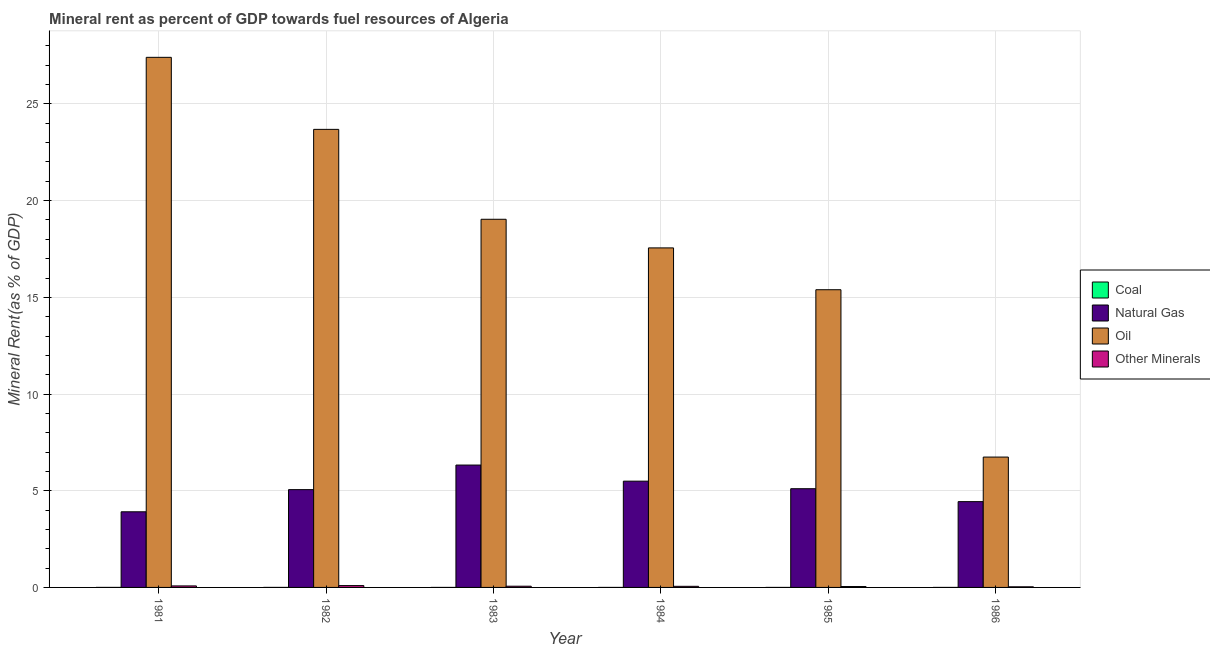How many groups of bars are there?
Provide a short and direct response. 6. Are the number of bars per tick equal to the number of legend labels?
Your response must be concise. Yes. Are the number of bars on each tick of the X-axis equal?
Make the answer very short. Yes. How many bars are there on the 2nd tick from the left?
Offer a terse response. 4. What is the label of the 1st group of bars from the left?
Your answer should be very brief. 1981. In how many cases, is the number of bars for a given year not equal to the number of legend labels?
Provide a short and direct response. 0. What is the oil rent in 1985?
Offer a terse response. 15.39. Across all years, what is the maximum  rent of other minerals?
Offer a very short reply. 0.09. Across all years, what is the minimum oil rent?
Provide a short and direct response. 6.74. In which year was the coal rent maximum?
Keep it short and to the point. 1982. In which year was the coal rent minimum?
Your response must be concise. 1986. What is the total natural gas rent in the graph?
Give a very brief answer. 30.33. What is the difference between the  rent of other minerals in 1982 and that in 1984?
Make the answer very short. 0.04. What is the difference between the natural gas rent in 1982 and the  rent of other minerals in 1986?
Ensure brevity in your answer.  0.62. What is the average coal rent per year?
Make the answer very short. 0. In how many years, is the  rent of other minerals greater than 21 %?
Your response must be concise. 0. What is the ratio of the  rent of other minerals in 1982 to that in 1984?
Your answer should be compact. 1.66. What is the difference between the highest and the second highest  rent of other minerals?
Ensure brevity in your answer.  0.02. What is the difference between the highest and the lowest  rent of other minerals?
Provide a succinct answer. 0.06. What does the 1st bar from the left in 1984 represents?
Your answer should be very brief. Coal. What does the 1st bar from the right in 1985 represents?
Give a very brief answer. Other Minerals. How many bars are there?
Your answer should be very brief. 24. Are all the bars in the graph horizontal?
Offer a very short reply. No. How many years are there in the graph?
Offer a very short reply. 6. What is the difference between two consecutive major ticks on the Y-axis?
Offer a very short reply. 5. Are the values on the major ticks of Y-axis written in scientific E-notation?
Your answer should be very brief. No. Does the graph contain any zero values?
Your answer should be compact. No. Does the graph contain grids?
Provide a short and direct response. Yes. What is the title of the graph?
Offer a terse response. Mineral rent as percent of GDP towards fuel resources of Algeria. What is the label or title of the Y-axis?
Ensure brevity in your answer.  Mineral Rent(as % of GDP). What is the Mineral Rent(as % of GDP) of Coal in 1981?
Your answer should be very brief. 0. What is the Mineral Rent(as % of GDP) in Natural Gas in 1981?
Make the answer very short. 3.91. What is the Mineral Rent(as % of GDP) in Oil in 1981?
Make the answer very short. 27.41. What is the Mineral Rent(as % of GDP) of Other Minerals in 1981?
Keep it short and to the point. 0.08. What is the Mineral Rent(as % of GDP) in Coal in 1982?
Make the answer very short. 0. What is the Mineral Rent(as % of GDP) of Natural Gas in 1982?
Provide a succinct answer. 5.06. What is the Mineral Rent(as % of GDP) in Oil in 1982?
Your answer should be compact. 23.69. What is the Mineral Rent(as % of GDP) of Other Minerals in 1982?
Ensure brevity in your answer.  0.09. What is the Mineral Rent(as % of GDP) of Coal in 1983?
Your answer should be compact. 0. What is the Mineral Rent(as % of GDP) in Natural Gas in 1983?
Your answer should be compact. 6.33. What is the Mineral Rent(as % of GDP) of Oil in 1983?
Your answer should be very brief. 19.04. What is the Mineral Rent(as % of GDP) of Other Minerals in 1983?
Give a very brief answer. 0.06. What is the Mineral Rent(as % of GDP) of Coal in 1984?
Your answer should be very brief. 6.52912655872695e-5. What is the Mineral Rent(as % of GDP) of Natural Gas in 1984?
Your response must be concise. 5.49. What is the Mineral Rent(as % of GDP) in Oil in 1984?
Provide a short and direct response. 17.56. What is the Mineral Rent(as % of GDP) of Other Minerals in 1984?
Your answer should be compact. 0.06. What is the Mineral Rent(as % of GDP) in Coal in 1985?
Keep it short and to the point. 0. What is the Mineral Rent(as % of GDP) in Natural Gas in 1985?
Your answer should be compact. 5.1. What is the Mineral Rent(as % of GDP) in Oil in 1985?
Provide a succinct answer. 15.39. What is the Mineral Rent(as % of GDP) of Other Minerals in 1985?
Offer a very short reply. 0.05. What is the Mineral Rent(as % of GDP) in Coal in 1986?
Provide a short and direct response. 1.11843058632871e-6. What is the Mineral Rent(as % of GDP) in Natural Gas in 1986?
Your answer should be very brief. 4.44. What is the Mineral Rent(as % of GDP) in Oil in 1986?
Offer a terse response. 6.74. What is the Mineral Rent(as % of GDP) in Other Minerals in 1986?
Provide a short and direct response. 0.03. Across all years, what is the maximum Mineral Rent(as % of GDP) of Coal?
Your answer should be very brief. 0. Across all years, what is the maximum Mineral Rent(as % of GDP) of Natural Gas?
Keep it short and to the point. 6.33. Across all years, what is the maximum Mineral Rent(as % of GDP) of Oil?
Your response must be concise. 27.41. Across all years, what is the maximum Mineral Rent(as % of GDP) of Other Minerals?
Offer a very short reply. 0.09. Across all years, what is the minimum Mineral Rent(as % of GDP) in Coal?
Make the answer very short. 1.11843058632871e-6. Across all years, what is the minimum Mineral Rent(as % of GDP) in Natural Gas?
Provide a succinct answer. 3.91. Across all years, what is the minimum Mineral Rent(as % of GDP) in Oil?
Offer a very short reply. 6.74. Across all years, what is the minimum Mineral Rent(as % of GDP) in Other Minerals?
Make the answer very short. 0.03. What is the total Mineral Rent(as % of GDP) of Coal in the graph?
Your answer should be compact. 0. What is the total Mineral Rent(as % of GDP) in Natural Gas in the graph?
Make the answer very short. 30.33. What is the total Mineral Rent(as % of GDP) in Oil in the graph?
Provide a short and direct response. 109.82. What is the total Mineral Rent(as % of GDP) of Other Minerals in the graph?
Give a very brief answer. 0.37. What is the difference between the Mineral Rent(as % of GDP) of Natural Gas in 1981 and that in 1982?
Your response must be concise. -1.15. What is the difference between the Mineral Rent(as % of GDP) of Oil in 1981 and that in 1982?
Provide a short and direct response. 3.73. What is the difference between the Mineral Rent(as % of GDP) of Other Minerals in 1981 and that in 1982?
Make the answer very short. -0.02. What is the difference between the Mineral Rent(as % of GDP) in Coal in 1981 and that in 1983?
Your answer should be compact. 0. What is the difference between the Mineral Rent(as % of GDP) in Natural Gas in 1981 and that in 1983?
Give a very brief answer. -2.42. What is the difference between the Mineral Rent(as % of GDP) of Oil in 1981 and that in 1983?
Give a very brief answer. 8.37. What is the difference between the Mineral Rent(as % of GDP) in Other Minerals in 1981 and that in 1983?
Offer a terse response. 0.02. What is the difference between the Mineral Rent(as % of GDP) of Coal in 1981 and that in 1984?
Offer a terse response. 0. What is the difference between the Mineral Rent(as % of GDP) of Natural Gas in 1981 and that in 1984?
Give a very brief answer. -1.58. What is the difference between the Mineral Rent(as % of GDP) of Oil in 1981 and that in 1984?
Give a very brief answer. 9.85. What is the difference between the Mineral Rent(as % of GDP) in Other Minerals in 1981 and that in 1984?
Offer a very short reply. 0.02. What is the difference between the Mineral Rent(as % of GDP) in Coal in 1981 and that in 1985?
Give a very brief answer. 0. What is the difference between the Mineral Rent(as % of GDP) of Natural Gas in 1981 and that in 1985?
Provide a succinct answer. -1.19. What is the difference between the Mineral Rent(as % of GDP) of Oil in 1981 and that in 1985?
Provide a succinct answer. 12.02. What is the difference between the Mineral Rent(as % of GDP) in Other Minerals in 1981 and that in 1985?
Keep it short and to the point. 0.03. What is the difference between the Mineral Rent(as % of GDP) in Coal in 1981 and that in 1986?
Ensure brevity in your answer.  0. What is the difference between the Mineral Rent(as % of GDP) in Natural Gas in 1981 and that in 1986?
Give a very brief answer. -0.53. What is the difference between the Mineral Rent(as % of GDP) of Oil in 1981 and that in 1986?
Your response must be concise. 20.67. What is the difference between the Mineral Rent(as % of GDP) of Other Minerals in 1981 and that in 1986?
Your response must be concise. 0.05. What is the difference between the Mineral Rent(as % of GDP) in Natural Gas in 1982 and that in 1983?
Provide a succinct answer. -1.27. What is the difference between the Mineral Rent(as % of GDP) in Oil in 1982 and that in 1983?
Provide a succinct answer. 4.65. What is the difference between the Mineral Rent(as % of GDP) of Other Minerals in 1982 and that in 1983?
Your answer should be very brief. 0.03. What is the difference between the Mineral Rent(as % of GDP) in Natural Gas in 1982 and that in 1984?
Your answer should be compact. -0.44. What is the difference between the Mineral Rent(as % of GDP) in Oil in 1982 and that in 1984?
Your answer should be very brief. 6.13. What is the difference between the Mineral Rent(as % of GDP) of Other Minerals in 1982 and that in 1984?
Provide a short and direct response. 0.04. What is the difference between the Mineral Rent(as % of GDP) in Coal in 1982 and that in 1985?
Keep it short and to the point. 0. What is the difference between the Mineral Rent(as % of GDP) of Natural Gas in 1982 and that in 1985?
Your answer should be very brief. -0.05. What is the difference between the Mineral Rent(as % of GDP) in Oil in 1982 and that in 1985?
Ensure brevity in your answer.  8.29. What is the difference between the Mineral Rent(as % of GDP) of Other Minerals in 1982 and that in 1985?
Keep it short and to the point. 0.05. What is the difference between the Mineral Rent(as % of GDP) in Natural Gas in 1982 and that in 1986?
Your response must be concise. 0.62. What is the difference between the Mineral Rent(as % of GDP) in Oil in 1982 and that in 1986?
Provide a succinct answer. 16.95. What is the difference between the Mineral Rent(as % of GDP) of Other Minerals in 1982 and that in 1986?
Offer a very short reply. 0.06. What is the difference between the Mineral Rent(as % of GDP) in Coal in 1983 and that in 1984?
Your response must be concise. 0. What is the difference between the Mineral Rent(as % of GDP) in Natural Gas in 1983 and that in 1984?
Keep it short and to the point. 0.83. What is the difference between the Mineral Rent(as % of GDP) of Oil in 1983 and that in 1984?
Provide a succinct answer. 1.48. What is the difference between the Mineral Rent(as % of GDP) of Other Minerals in 1983 and that in 1984?
Your response must be concise. 0.01. What is the difference between the Mineral Rent(as % of GDP) of Natural Gas in 1983 and that in 1985?
Your answer should be compact. 1.22. What is the difference between the Mineral Rent(as % of GDP) of Oil in 1983 and that in 1985?
Your answer should be compact. 3.64. What is the difference between the Mineral Rent(as % of GDP) in Other Minerals in 1983 and that in 1985?
Your answer should be very brief. 0.02. What is the difference between the Mineral Rent(as % of GDP) of Coal in 1983 and that in 1986?
Make the answer very short. 0. What is the difference between the Mineral Rent(as % of GDP) of Natural Gas in 1983 and that in 1986?
Offer a terse response. 1.89. What is the difference between the Mineral Rent(as % of GDP) of Oil in 1983 and that in 1986?
Offer a terse response. 12.3. What is the difference between the Mineral Rent(as % of GDP) in Other Minerals in 1983 and that in 1986?
Offer a very short reply. 0.03. What is the difference between the Mineral Rent(as % of GDP) in Natural Gas in 1984 and that in 1985?
Make the answer very short. 0.39. What is the difference between the Mineral Rent(as % of GDP) in Oil in 1984 and that in 1985?
Ensure brevity in your answer.  2.16. What is the difference between the Mineral Rent(as % of GDP) of Other Minerals in 1984 and that in 1985?
Provide a short and direct response. 0.01. What is the difference between the Mineral Rent(as % of GDP) of Coal in 1984 and that in 1986?
Offer a terse response. 0. What is the difference between the Mineral Rent(as % of GDP) in Natural Gas in 1984 and that in 1986?
Offer a terse response. 1.06. What is the difference between the Mineral Rent(as % of GDP) in Oil in 1984 and that in 1986?
Offer a very short reply. 10.82. What is the difference between the Mineral Rent(as % of GDP) of Other Minerals in 1984 and that in 1986?
Give a very brief answer. 0.03. What is the difference between the Mineral Rent(as % of GDP) in Coal in 1985 and that in 1986?
Your answer should be very brief. 0. What is the difference between the Mineral Rent(as % of GDP) in Natural Gas in 1985 and that in 1986?
Ensure brevity in your answer.  0.67. What is the difference between the Mineral Rent(as % of GDP) of Oil in 1985 and that in 1986?
Ensure brevity in your answer.  8.65. What is the difference between the Mineral Rent(as % of GDP) in Other Minerals in 1985 and that in 1986?
Make the answer very short. 0.01. What is the difference between the Mineral Rent(as % of GDP) in Coal in 1981 and the Mineral Rent(as % of GDP) in Natural Gas in 1982?
Ensure brevity in your answer.  -5.06. What is the difference between the Mineral Rent(as % of GDP) of Coal in 1981 and the Mineral Rent(as % of GDP) of Oil in 1982?
Make the answer very short. -23.69. What is the difference between the Mineral Rent(as % of GDP) in Coal in 1981 and the Mineral Rent(as % of GDP) in Other Minerals in 1982?
Give a very brief answer. -0.09. What is the difference between the Mineral Rent(as % of GDP) in Natural Gas in 1981 and the Mineral Rent(as % of GDP) in Oil in 1982?
Your answer should be compact. -19.77. What is the difference between the Mineral Rent(as % of GDP) of Natural Gas in 1981 and the Mineral Rent(as % of GDP) of Other Minerals in 1982?
Offer a very short reply. 3.82. What is the difference between the Mineral Rent(as % of GDP) of Oil in 1981 and the Mineral Rent(as % of GDP) of Other Minerals in 1982?
Your response must be concise. 27.32. What is the difference between the Mineral Rent(as % of GDP) of Coal in 1981 and the Mineral Rent(as % of GDP) of Natural Gas in 1983?
Provide a short and direct response. -6.33. What is the difference between the Mineral Rent(as % of GDP) in Coal in 1981 and the Mineral Rent(as % of GDP) in Oil in 1983?
Your answer should be very brief. -19.04. What is the difference between the Mineral Rent(as % of GDP) of Coal in 1981 and the Mineral Rent(as % of GDP) of Other Minerals in 1983?
Keep it short and to the point. -0.06. What is the difference between the Mineral Rent(as % of GDP) of Natural Gas in 1981 and the Mineral Rent(as % of GDP) of Oil in 1983?
Provide a succinct answer. -15.13. What is the difference between the Mineral Rent(as % of GDP) in Natural Gas in 1981 and the Mineral Rent(as % of GDP) in Other Minerals in 1983?
Keep it short and to the point. 3.85. What is the difference between the Mineral Rent(as % of GDP) of Oil in 1981 and the Mineral Rent(as % of GDP) of Other Minerals in 1983?
Make the answer very short. 27.35. What is the difference between the Mineral Rent(as % of GDP) of Coal in 1981 and the Mineral Rent(as % of GDP) of Natural Gas in 1984?
Provide a succinct answer. -5.49. What is the difference between the Mineral Rent(as % of GDP) of Coal in 1981 and the Mineral Rent(as % of GDP) of Oil in 1984?
Make the answer very short. -17.56. What is the difference between the Mineral Rent(as % of GDP) of Coal in 1981 and the Mineral Rent(as % of GDP) of Other Minerals in 1984?
Ensure brevity in your answer.  -0.06. What is the difference between the Mineral Rent(as % of GDP) in Natural Gas in 1981 and the Mineral Rent(as % of GDP) in Oil in 1984?
Provide a succinct answer. -13.65. What is the difference between the Mineral Rent(as % of GDP) of Natural Gas in 1981 and the Mineral Rent(as % of GDP) of Other Minerals in 1984?
Offer a terse response. 3.85. What is the difference between the Mineral Rent(as % of GDP) in Oil in 1981 and the Mineral Rent(as % of GDP) in Other Minerals in 1984?
Give a very brief answer. 27.35. What is the difference between the Mineral Rent(as % of GDP) of Coal in 1981 and the Mineral Rent(as % of GDP) of Natural Gas in 1985?
Your answer should be compact. -5.1. What is the difference between the Mineral Rent(as % of GDP) of Coal in 1981 and the Mineral Rent(as % of GDP) of Oil in 1985?
Your answer should be compact. -15.39. What is the difference between the Mineral Rent(as % of GDP) of Coal in 1981 and the Mineral Rent(as % of GDP) of Other Minerals in 1985?
Provide a succinct answer. -0.05. What is the difference between the Mineral Rent(as % of GDP) in Natural Gas in 1981 and the Mineral Rent(as % of GDP) in Oil in 1985?
Your answer should be very brief. -11.48. What is the difference between the Mineral Rent(as % of GDP) in Natural Gas in 1981 and the Mineral Rent(as % of GDP) in Other Minerals in 1985?
Ensure brevity in your answer.  3.86. What is the difference between the Mineral Rent(as % of GDP) in Oil in 1981 and the Mineral Rent(as % of GDP) in Other Minerals in 1985?
Provide a short and direct response. 27.36. What is the difference between the Mineral Rent(as % of GDP) of Coal in 1981 and the Mineral Rent(as % of GDP) of Natural Gas in 1986?
Make the answer very short. -4.44. What is the difference between the Mineral Rent(as % of GDP) of Coal in 1981 and the Mineral Rent(as % of GDP) of Oil in 1986?
Offer a terse response. -6.74. What is the difference between the Mineral Rent(as % of GDP) in Coal in 1981 and the Mineral Rent(as % of GDP) in Other Minerals in 1986?
Offer a very short reply. -0.03. What is the difference between the Mineral Rent(as % of GDP) in Natural Gas in 1981 and the Mineral Rent(as % of GDP) in Oil in 1986?
Your answer should be very brief. -2.83. What is the difference between the Mineral Rent(as % of GDP) in Natural Gas in 1981 and the Mineral Rent(as % of GDP) in Other Minerals in 1986?
Provide a short and direct response. 3.88. What is the difference between the Mineral Rent(as % of GDP) of Oil in 1981 and the Mineral Rent(as % of GDP) of Other Minerals in 1986?
Your answer should be very brief. 27.38. What is the difference between the Mineral Rent(as % of GDP) of Coal in 1982 and the Mineral Rent(as % of GDP) of Natural Gas in 1983?
Ensure brevity in your answer.  -6.33. What is the difference between the Mineral Rent(as % of GDP) of Coal in 1982 and the Mineral Rent(as % of GDP) of Oil in 1983?
Your answer should be compact. -19.04. What is the difference between the Mineral Rent(as % of GDP) in Coal in 1982 and the Mineral Rent(as % of GDP) in Other Minerals in 1983?
Ensure brevity in your answer.  -0.06. What is the difference between the Mineral Rent(as % of GDP) in Natural Gas in 1982 and the Mineral Rent(as % of GDP) in Oil in 1983?
Give a very brief answer. -13.98. What is the difference between the Mineral Rent(as % of GDP) of Natural Gas in 1982 and the Mineral Rent(as % of GDP) of Other Minerals in 1983?
Keep it short and to the point. 4.99. What is the difference between the Mineral Rent(as % of GDP) of Oil in 1982 and the Mineral Rent(as % of GDP) of Other Minerals in 1983?
Make the answer very short. 23.62. What is the difference between the Mineral Rent(as % of GDP) in Coal in 1982 and the Mineral Rent(as % of GDP) in Natural Gas in 1984?
Give a very brief answer. -5.49. What is the difference between the Mineral Rent(as % of GDP) in Coal in 1982 and the Mineral Rent(as % of GDP) in Oil in 1984?
Provide a short and direct response. -17.56. What is the difference between the Mineral Rent(as % of GDP) in Coal in 1982 and the Mineral Rent(as % of GDP) in Other Minerals in 1984?
Your answer should be compact. -0.06. What is the difference between the Mineral Rent(as % of GDP) in Natural Gas in 1982 and the Mineral Rent(as % of GDP) in Oil in 1984?
Offer a very short reply. -12.5. What is the difference between the Mineral Rent(as % of GDP) of Natural Gas in 1982 and the Mineral Rent(as % of GDP) of Other Minerals in 1984?
Your answer should be very brief. 5. What is the difference between the Mineral Rent(as % of GDP) of Oil in 1982 and the Mineral Rent(as % of GDP) of Other Minerals in 1984?
Offer a terse response. 23.63. What is the difference between the Mineral Rent(as % of GDP) in Coal in 1982 and the Mineral Rent(as % of GDP) in Natural Gas in 1985?
Ensure brevity in your answer.  -5.1. What is the difference between the Mineral Rent(as % of GDP) of Coal in 1982 and the Mineral Rent(as % of GDP) of Oil in 1985?
Provide a succinct answer. -15.39. What is the difference between the Mineral Rent(as % of GDP) of Coal in 1982 and the Mineral Rent(as % of GDP) of Other Minerals in 1985?
Give a very brief answer. -0.05. What is the difference between the Mineral Rent(as % of GDP) in Natural Gas in 1982 and the Mineral Rent(as % of GDP) in Oil in 1985?
Offer a terse response. -10.34. What is the difference between the Mineral Rent(as % of GDP) of Natural Gas in 1982 and the Mineral Rent(as % of GDP) of Other Minerals in 1985?
Your answer should be compact. 5.01. What is the difference between the Mineral Rent(as % of GDP) in Oil in 1982 and the Mineral Rent(as % of GDP) in Other Minerals in 1985?
Your answer should be very brief. 23.64. What is the difference between the Mineral Rent(as % of GDP) of Coal in 1982 and the Mineral Rent(as % of GDP) of Natural Gas in 1986?
Ensure brevity in your answer.  -4.44. What is the difference between the Mineral Rent(as % of GDP) of Coal in 1982 and the Mineral Rent(as % of GDP) of Oil in 1986?
Ensure brevity in your answer.  -6.74. What is the difference between the Mineral Rent(as % of GDP) of Coal in 1982 and the Mineral Rent(as % of GDP) of Other Minerals in 1986?
Your response must be concise. -0.03. What is the difference between the Mineral Rent(as % of GDP) in Natural Gas in 1982 and the Mineral Rent(as % of GDP) in Oil in 1986?
Your answer should be very brief. -1.68. What is the difference between the Mineral Rent(as % of GDP) of Natural Gas in 1982 and the Mineral Rent(as % of GDP) of Other Minerals in 1986?
Provide a short and direct response. 5.03. What is the difference between the Mineral Rent(as % of GDP) of Oil in 1982 and the Mineral Rent(as % of GDP) of Other Minerals in 1986?
Keep it short and to the point. 23.65. What is the difference between the Mineral Rent(as % of GDP) in Coal in 1983 and the Mineral Rent(as % of GDP) in Natural Gas in 1984?
Give a very brief answer. -5.49. What is the difference between the Mineral Rent(as % of GDP) in Coal in 1983 and the Mineral Rent(as % of GDP) in Oil in 1984?
Offer a very short reply. -17.56. What is the difference between the Mineral Rent(as % of GDP) of Coal in 1983 and the Mineral Rent(as % of GDP) of Other Minerals in 1984?
Provide a short and direct response. -0.06. What is the difference between the Mineral Rent(as % of GDP) in Natural Gas in 1983 and the Mineral Rent(as % of GDP) in Oil in 1984?
Make the answer very short. -11.23. What is the difference between the Mineral Rent(as % of GDP) in Natural Gas in 1983 and the Mineral Rent(as % of GDP) in Other Minerals in 1984?
Offer a terse response. 6.27. What is the difference between the Mineral Rent(as % of GDP) of Oil in 1983 and the Mineral Rent(as % of GDP) of Other Minerals in 1984?
Your answer should be compact. 18.98. What is the difference between the Mineral Rent(as % of GDP) of Coal in 1983 and the Mineral Rent(as % of GDP) of Natural Gas in 1985?
Ensure brevity in your answer.  -5.1. What is the difference between the Mineral Rent(as % of GDP) of Coal in 1983 and the Mineral Rent(as % of GDP) of Oil in 1985?
Your answer should be very brief. -15.39. What is the difference between the Mineral Rent(as % of GDP) in Coal in 1983 and the Mineral Rent(as % of GDP) in Other Minerals in 1985?
Offer a terse response. -0.05. What is the difference between the Mineral Rent(as % of GDP) in Natural Gas in 1983 and the Mineral Rent(as % of GDP) in Oil in 1985?
Your answer should be compact. -9.07. What is the difference between the Mineral Rent(as % of GDP) in Natural Gas in 1983 and the Mineral Rent(as % of GDP) in Other Minerals in 1985?
Your response must be concise. 6.28. What is the difference between the Mineral Rent(as % of GDP) in Oil in 1983 and the Mineral Rent(as % of GDP) in Other Minerals in 1985?
Your response must be concise. 18.99. What is the difference between the Mineral Rent(as % of GDP) of Coal in 1983 and the Mineral Rent(as % of GDP) of Natural Gas in 1986?
Provide a short and direct response. -4.44. What is the difference between the Mineral Rent(as % of GDP) of Coal in 1983 and the Mineral Rent(as % of GDP) of Oil in 1986?
Give a very brief answer. -6.74. What is the difference between the Mineral Rent(as % of GDP) in Coal in 1983 and the Mineral Rent(as % of GDP) in Other Minerals in 1986?
Ensure brevity in your answer.  -0.03. What is the difference between the Mineral Rent(as % of GDP) of Natural Gas in 1983 and the Mineral Rent(as % of GDP) of Oil in 1986?
Make the answer very short. -0.41. What is the difference between the Mineral Rent(as % of GDP) in Natural Gas in 1983 and the Mineral Rent(as % of GDP) in Other Minerals in 1986?
Offer a terse response. 6.3. What is the difference between the Mineral Rent(as % of GDP) of Oil in 1983 and the Mineral Rent(as % of GDP) of Other Minerals in 1986?
Give a very brief answer. 19.01. What is the difference between the Mineral Rent(as % of GDP) in Coal in 1984 and the Mineral Rent(as % of GDP) in Natural Gas in 1985?
Your response must be concise. -5.1. What is the difference between the Mineral Rent(as % of GDP) of Coal in 1984 and the Mineral Rent(as % of GDP) of Oil in 1985?
Offer a very short reply. -15.39. What is the difference between the Mineral Rent(as % of GDP) in Coal in 1984 and the Mineral Rent(as % of GDP) in Other Minerals in 1985?
Your answer should be very brief. -0.05. What is the difference between the Mineral Rent(as % of GDP) of Natural Gas in 1984 and the Mineral Rent(as % of GDP) of Oil in 1985?
Your response must be concise. -9.9. What is the difference between the Mineral Rent(as % of GDP) in Natural Gas in 1984 and the Mineral Rent(as % of GDP) in Other Minerals in 1985?
Your response must be concise. 5.45. What is the difference between the Mineral Rent(as % of GDP) in Oil in 1984 and the Mineral Rent(as % of GDP) in Other Minerals in 1985?
Your answer should be very brief. 17.51. What is the difference between the Mineral Rent(as % of GDP) in Coal in 1984 and the Mineral Rent(as % of GDP) in Natural Gas in 1986?
Provide a succinct answer. -4.44. What is the difference between the Mineral Rent(as % of GDP) of Coal in 1984 and the Mineral Rent(as % of GDP) of Oil in 1986?
Ensure brevity in your answer.  -6.74. What is the difference between the Mineral Rent(as % of GDP) in Coal in 1984 and the Mineral Rent(as % of GDP) in Other Minerals in 1986?
Keep it short and to the point. -0.03. What is the difference between the Mineral Rent(as % of GDP) of Natural Gas in 1984 and the Mineral Rent(as % of GDP) of Oil in 1986?
Provide a succinct answer. -1.25. What is the difference between the Mineral Rent(as % of GDP) of Natural Gas in 1984 and the Mineral Rent(as % of GDP) of Other Minerals in 1986?
Provide a short and direct response. 5.46. What is the difference between the Mineral Rent(as % of GDP) in Oil in 1984 and the Mineral Rent(as % of GDP) in Other Minerals in 1986?
Provide a short and direct response. 17.53. What is the difference between the Mineral Rent(as % of GDP) in Coal in 1985 and the Mineral Rent(as % of GDP) in Natural Gas in 1986?
Your response must be concise. -4.44. What is the difference between the Mineral Rent(as % of GDP) of Coal in 1985 and the Mineral Rent(as % of GDP) of Oil in 1986?
Your answer should be very brief. -6.74. What is the difference between the Mineral Rent(as % of GDP) of Coal in 1985 and the Mineral Rent(as % of GDP) of Other Minerals in 1986?
Offer a terse response. -0.03. What is the difference between the Mineral Rent(as % of GDP) in Natural Gas in 1985 and the Mineral Rent(as % of GDP) in Oil in 1986?
Ensure brevity in your answer.  -1.64. What is the difference between the Mineral Rent(as % of GDP) in Natural Gas in 1985 and the Mineral Rent(as % of GDP) in Other Minerals in 1986?
Provide a short and direct response. 5.07. What is the difference between the Mineral Rent(as % of GDP) in Oil in 1985 and the Mineral Rent(as % of GDP) in Other Minerals in 1986?
Make the answer very short. 15.36. What is the average Mineral Rent(as % of GDP) in Natural Gas per year?
Offer a terse response. 5.06. What is the average Mineral Rent(as % of GDP) in Oil per year?
Offer a very short reply. 18.3. What is the average Mineral Rent(as % of GDP) in Other Minerals per year?
Offer a terse response. 0.06. In the year 1981, what is the difference between the Mineral Rent(as % of GDP) of Coal and Mineral Rent(as % of GDP) of Natural Gas?
Keep it short and to the point. -3.91. In the year 1981, what is the difference between the Mineral Rent(as % of GDP) in Coal and Mineral Rent(as % of GDP) in Oil?
Keep it short and to the point. -27.41. In the year 1981, what is the difference between the Mineral Rent(as % of GDP) in Coal and Mineral Rent(as % of GDP) in Other Minerals?
Provide a short and direct response. -0.08. In the year 1981, what is the difference between the Mineral Rent(as % of GDP) of Natural Gas and Mineral Rent(as % of GDP) of Oil?
Your response must be concise. -23.5. In the year 1981, what is the difference between the Mineral Rent(as % of GDP) of Natural Gas and Mineral Rent(as % of GDP) of Other Minerals?
Your response must be concise. 3.83. In the year 1981, what is the difference between the Mineral Rent(as % of GDP) of Oil and Mineral Rent(as % of GDP) of Other Minerals?
Offer a very short reply. 27.33. In the year 1982, what is the difference between the Mineral Rent(as % of GDP) in Coal and Mineral Rent(as % of GDP) in Natural Gas?
Provide a short and direct response. -5.06. In the year 1982, what is the difference between the Mineral Rent(as % of GDP) of Coal and Mineral Rent(as % of GDP) of Oil?
Your response must be concise. -23.69. In the year 1982, what is the difference between the Mineral Rent(as % of GDP) in Coal and Mineral Rent(as % of GDP) in Other Minerals?
Offer a very short reply. -0.09. In the year 1982, what is the difference between the Mineral Rent(as % of GDP) of Natural Gas and Mineral Rent(as % of GDP) of Oil?
Provide a short and direct response. -18.63. In the year 1982, what is the difference between the Mineral Rent(as % of GDP) in Natural Gas and Mineral Rent(as % of GDP) in Other Minerals?
Keep it short and to the point. 4.96. In the year 1982, what is the difference between the Mineral Rent(as % of GDP) of Oil and Mineral Rent(as % of GDP) of Other Minerals?
Your response must be concise. 23.59. In the year 1983, what is the difference between the Mineral Rent(as % of GDP) of Coal and Mineral Rent(as % of GDP) of Natural Gas?
Give a very brief answer. -6.33. In the year 1983, what is the difference between the Mineral Rent(as % of GDP) of Coal and Mineral Rent(as % of GDP) of Oil?
Give a very brief answer. -19.04. In the year 1983, what is the difference between the Mineral Rent(as % of GDP) of Coal and Mineral Rent(as % of GDP) of Other Minerals?
Your answer should be compact. -0.06. In the year 1983, what is the difference between the Mineral Rent(as % of GDP) in Natural Gas and Mineral Rent(as % of GDP) in Oil?
Keep it short and to the point. -12.71. In the year 1983, what is the difference between the Mineral Rent(as % of GDP) of Natural Gas and Mineral Rent(as % of GDP) of Other Minerals?
Ensure brevity in your answer.  6.27. In the year 1983, what is the difference between the Mineral Rent(as % of GDP) of Oil and Mineral Rent(as % of GDP) of Other Minerals?
Your answer should be compact. 18.97. In the year 1984, what is the difference between the Mineral Rent(as % of GDP) in Coal and Mineral Rent(as % of GDP) in Natural Gas?
Keep it short and to the point. -5.49. In the year 1984, what is the difference between the Mineral Rent(as % of GDP) in Coal and Mineral Rent(as % of GDP) in Oil?
Your answer should be very brief. -17.56. In the year 1984, what is the difference between the Mineral Rent(as % of GDP) in Coal and Mineral Rent(as % of GDP) in Other Minerals?
Give a very brief answer. -0.06. In the year 1984, what is the difference between the Mineral Rent(as % of GDP) of Natural Gas and Mineral Rent(as % of GDP) of Oil?
Offer a terse response. -12.06. In the year 1984, what is the difference between the Mineral Rent(as % of GDP) of Natural Gas and Mineral Rent(as % of GDP) of Other Minerals?
Give a very brief answer. 5.44. In the year 1984, what is the difference between the Mineral Rent(as % of GDP) of Oil and Mineral Rent(as % of GDP) of Other Minerals?
Keep it short and to the point. 17.5. In the year 1985, what is the difference between the Mineral Rent(as % of GDP) in Coal and Mineral Rent(as % of GDP) in Natural Gas?
Provide a short and direct response. -5.1. In the year 1985, what is the difference between the Mineral Rent(as % of GDP) in Coal and Mineral Rent(as % of GDP) in Oil?
Provide a short and direct response. -15.39. In the year 1985, what is the difference between the Mineral Rent(as % of GDP) of Coal and Mineral Rent(as % of GDP) of Other Minerals?
Provide a short and direct response. -0.05. In the year 1985, what is the difference between the Mineral Rent(as % of GDP) in Natural Gas and Mineral Rent(as % of GDP) in Oil?
Your answer should be very brief. -10.29. In the year 1985, what is the difference between the Mineral Rent(as % of GDP) in Natural Gas and Mineral Rent(as % of GDP) in Other Minerals?
Offer a very short reply. 5.06. In the year 1985, what is the difference between the Mineral Rent(as % of GDP) of Oil and Mineral Rent(as % of GDP) of Other Minerals?
Ensure brevity in your answer.  15.35. In the year 1986, what is the difference between the Mineral Rent(as % of GDP) of Coal and Mineral Rent(as % of GDP) of Natural Gas?
Offer a very short reply. -4.44. In the year 1986, what is the difference between the Mineral Rent(as % of GDP) of Coal and Mineral Rent(as % of GDP) of Oil?
Provide a succinct answer. -6.74. In the year 1986, what is the difference between the Mineral Rent(as % of GDP) in Coal and Mineral Rent(as % of GDP) in Other Minerals?
Your answer should be very brief. -0.03. In the year 1986, what is the difference between the Mineral Rent(as % of GDP) of Natural Gas and Mineral Rent(as % of GDP) of Oil?
Keep it short and to the point. -2.3. In the year 1986, what is the difference between the Mineral Rent(as % of GDP) of Natural Gas and Mineral Rent(as % of GDP) of Other Minerals?
Make the answer very short. 4.4. In the year 1986, what is the difference between the Mineral Rent(as % of GDP) of Oil and Mineral Rent(as % of GDP) of Other Minerals?
Your answer should be very brief. 6.71. What is the ratio of the Mineral Rent(as % of GDP) in Coal in 1981 to that in 1982?
Provide a succinct answer. 0.94. What is the ratio of the Mineral Rent(as % of GDP) of Natural Gas in 1981 to that in 1982?
Give a very brief answer. 0.77. What is the ratio of the Mineral Rent(as % of GDP) in Oil in 1981 to that in 1982?
Your answer should be very brief. 1.16. What is the ratio of the Mineral Rent(as % of GDP) in Other Minerals in 1981 to that in 1982?
Give a very brief answer. 0.82. What is the ratio of the Mineral Rent(as % of GDP) in Coal in 1981 to that in 1983?
Provide a short and direct response. 2.63. What is the ratio of the Mineral Rent(as % of GDP) in Natural Gas in 1981 to that in 1983?
Keep it short and to the point. 0.62. What is the ratio of the Mineral Rent(as % of GDP) in Oil in 1981 to that in 1983?
Your answer should be compact. 1.44. What is the ratio of the Mineral Rent(as % of GDP) of Other Minerals in 1981 to that in 1983?
Provide a short and direct response. 1.25. What is the ratio of the Mineral Rent(as % of GDP) of Coal in 1981 to that in 1984?
Give a very brief answer. 5.77. What is the ratio of the Mineral Rent(as % of GDP) of Natural Gas in 1981 to that in 1984?
Give a very brief answer. 0.71. What is the ratio of the Mineral Rent(as % of GDP) of Oil in 1981 to that in 1984?
Make the answer very short. 1.56. What is the ratio of the Mineral Rent(as % of GDP) in Other Minerals in 1981 to that in 1984?
Make the answer very short. 1.37. What is the ratio of the Mineral Rent(as % of GDP) in Coal in 1981 to that in 1985?
Offer a very short reply. 3.49. What is the ratio of the Mineral Rent(as % of GDP) of Natural Gas in 1981 to that in 1985?
Your answer should be very brief. 0.77. What is the ratio of the Mineral Rent(as % of GDP) of Oil in 1981 to that in 1985?
Keep it short and to the point. 1.78. What is the ratio of the Mineral Rent(as % of GDP) of Other Minerals in 1981 to that in 1985?
Keep it short and to the point. 1.7. What is the ratio of the Mineral Rent(as % of GDP) of Coal in 1981 to that in 1986?
Provide a succinct answer. 337.07. What is the ratio of the Mineral Rent(as % of GDP) of Natural Gas in 1981 to that in 1986?
Give a very brief answer. 0.88. What is the ratio of the Mineral Rent(as % of GDP) in Oil in 1981 to that in 1986?
Your answer should be compact. 4.07. What is the ratio of the Mineral Rent(as % of GDP) of Other Minerals in 1981 to that in 1986?
Ensure brevity in your answer.  2.46. What is the ratio of the Mineral Rent(as % of GDP) of Coal in 1982 to that in 1983?
Your answer should be very brief. 2.81. What is the ratio of the Mineral Rent(as % of GDP) of Natural Gas in 1982 to that in 1983?
Your answer should be compact. 0.8. What is the ratio of the Mineral Rent(as % of GDP) in Oil in 1982 to that in 1983?
Make the answer very short. 1.24. What is the ratio of the Mineral Rent(as % of GDP) in Other Minerals in 1982 to that in 1983?
Give a very brief answer. 1.52. What is the ratio of the Mineral Rent(as % of GDP) of Coal in 1982 to that in 1984?
Make the answer very short. 6.15. What is the ratio of the Mineral Rent(as % of GDP) in Natural Gas in 1982 to that in 1984?
Give a very brief answer. 0.92. What is the ratio of the Mineral Rent(as % of GDP) of Oil in 1982 to that in 1984?
Your answer should be very brief. 1.35. What is the ratio of the Mineral Rent(as % of GDP) of Other Minerals in 1982 to that in 1984?
Provide a short and direct response. 1.66. What is the ratio of the Mineral Rent(as % of GDP) of Coal in 1982 to that in 1985?
Your answer should be compact. 3.72. What is the ratio of the Mineral Rent(as % of GDP) of Natural Gas in 1982 to that in 1985?
Keep it short and to the point. 0.99. What is the ratio of the Mineral Rent(as % of GDP) in Oil in 1982 to that in 1985?
Make the answer very short. 1.54. What is the ratio of the Mineral Rent(as % of GDP) in Other Minerals in 1982 to that in 1985?
Give a very brief answer. 2.06. What is the ratio of the Mineral Rent(as % of GDP) in Coal in 1982 to that in 1986?
Make the answer very short. 359.19. What is the ratio of the Mineral Rent(as % of GDP) in Natural Gas in 1982 to that in 1986?
Your answer should be compact. 1.14. What is the ratio of the Mineral Rent(as % of GDP) in Oil in 1982 to that in 1986?
Provide a short and direct response. 3.51. What is the ratio of the Mineral Rent(as % of GDP) in Other Minerals in 1982 to that in 1986?
Provide a short and direct response. 2.99. What is the ratio of the Mineral Rent(as % of GDP) of Coal in 1983 to that in 1984?
Ensure brevity in your answer.  2.19. What is the ratio of the Mineral Rent(as % of GDP) of Natural Gas in 1983 to that in 1984?
Provide a succinct answer. 1.15. What is the ratio of the Mineral Rent(as % of GDP) in Oil in 1983 to that in 1984?
Keep it short and to the point. 1.08. What is the ratio of the Mineral Rent(as % of GDP) in Other Minerals in 1983 to that in 1984?
Provide a short and direct response. 1.09. What is the ratio of the Mineral Rent(as % of GDP) in Coal in 1983 to that in 1985?
Offer a terse response. 1.32. What is the ratio of the Mineral Rent(as % of GDP) of Natural Gas in 1983 to that in 1985?
Give a very brief answer. 1.24. What is the ratio of the Mineral Rent(as % of GDP) of Oil in 1983 to that in 1985?
Offer a very short reply. 1.24. What is the ratio of the Mineral Rent(as % of GDP) in Other Minerals in 1983 to that in 1985?
Offer a terse response. 1.36. What is the ratio of the Mineral Rent(as % of GDP) of Coal in 1983 to that in 1986?
Keep it short and to the point. 127.94. What is the ratio of the Mineral Rent(as % of GDP) in Natural Gas in 1983 to that in 1986?
Offer a very short reply. 1.43. What is the ratio of the Mineral Rent(as % of GDP) in Oil in 1983 to that in 1986?
Give a very brief answer. 2.82. What is the ratio of the Mineral Rent(as % of GDP) in Other Minerals in 1983 to that in 1986?
Ensure brevity in your answer.  1.97. What is the ratio of the Mineral Rent(as % of GDP) of Coal in 1984 to that in 1985?
Provide a short and direct response. 0.6. What is the ratio of the Mineral Rent(as % of GDP) of Natural Gas in 1984 to that in 1985?
Give a very brief answer. 1.08. What is the ratio of the Mineral Rent(as % of GDP) in Oil in 1984 to that in 1985?
Keep it short and to the point. 1.14. What is the ratio of the Mineral Rent(as % of GDP) of Other Minerals in 1984 to that in 1985?
Keep it short and to the point. 1.24. What is the ratio of the Mineral Rent(as % of GDP) in Coal in 1984 to that in 1986?
Make the answer very short. 58.38. What is the ratio of the Mineral Rent(as % of GDP) of Natural Gas in 1984 to that in 1986?
Offer a terse response. 1.24. What is the ratio of the Mineral Rent(as % of GDP) of Oil in 1984 to that in 1986?
Give a very brief answer. 2.6. What is the ratio of the Mineral Rent(as % of GDP) of Other Minerals in 1984 to that in 1986?
Give a very brief answer. 1.8. What is the ratio of the Mineral Rent(as % of GDP) of Coal in 1985 to that in 1986?
Ensure brevity in your answer.  96.59. What is the ratio of the Mineral Rent(as % of GDP) of Natural Gas in 1985 to that in 1986?
Make the answer very short. 1.15. What is the ratio of the Mineral Rent(as % of GDP) of Oil in 1985 to that in 1986?
Provide a short and direct response. 2.28. What is the ratio of the Mineral Rent(as % of GDP) of Other Minerals in 1985 to that in 1986?
Give a very brief answer. 1.45. What is the difference between the highest and the second highest Mineral Rent(as % of GDP) of Coal?
Keep it short and to the point. 0. What is the difference between the highest and the second highest Mineral Rent(as % of GDP) of Natural Gas?
Your answer should be very brief. 0.83. What is the difference between the highest and the second highest Mineral Rent(as % of GDP) in Oil?
Offer a terse response. 3.73. What is the difference between the highest and the second highest Mineral Rent(as % of GDP) of Other Minerals?
Offer a very short reply. 0.02. What is the difference between the highest and the lowest Mineral Rent(as % of GDP) of Coal?
Your response must be concise. 0. What is the difference between the highest and the lowest Mineral Rent(as % of GDP) in Natural Gas?
Give a very brief answer. 2.42. What is the difference between the highest and the lowest Mineral Rent(as % of GDP) in Oil?
Provide a succinct answer. 20.67. What is the difference between the highest and the lowest Mineral Rent(as % of GDP) of Other Minerals?
Make the answer very short. 0.06. 